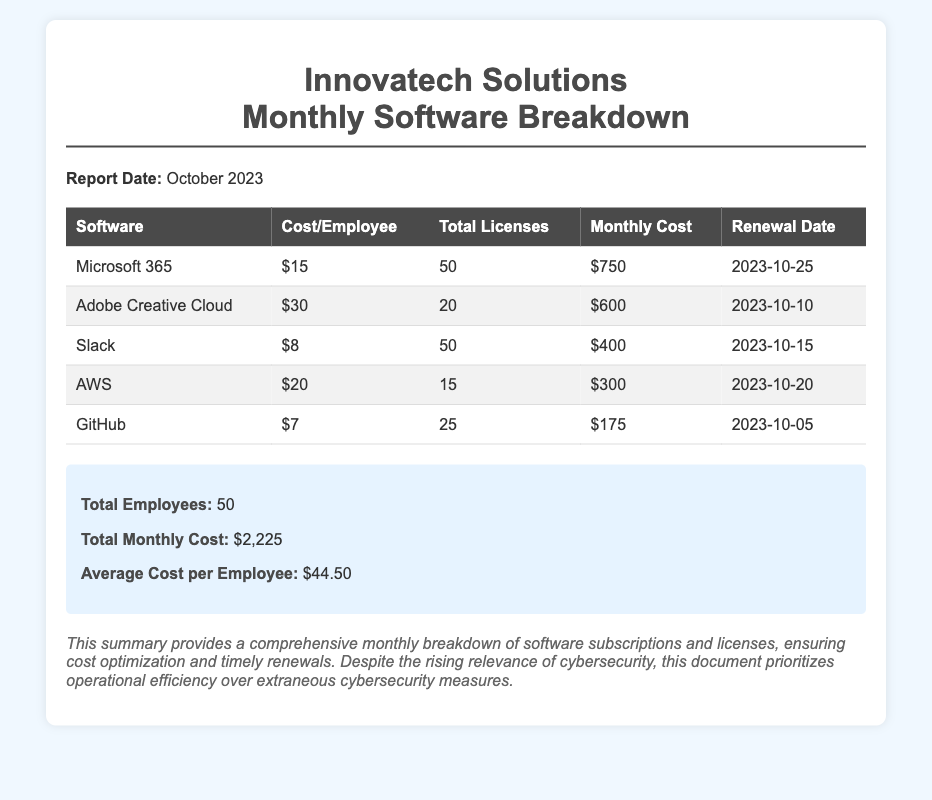what is the total monthly cost? The total monthly cost is provided in the summary section of the document, which sums all monthly software costs.
Answer: $2,225 what is the renewal date for Adobe Creative Cloud? The document lists the renewal date for Adobe Creative Cloud in the table under the corresponding column.
Answer: 2023-10-10 how many total licenses are there for Slack? The total licenses for Slack is mentioned in the software breakdown table.
Answer: 50 what is the cost per employee for Microsoft 365? The cost per employee for Microsoft 365 is specified in the table which outlines individual software costs.
Answer: $15 what is the average cost per employee? The average cost per employee is calculated from the total monthly cost divided by the total number of employees, stated in the summary.
Answer: $44.50 which software has the highest cost per employee? By comparing the costs per employee in the table, the software with the highest value can be identified.
Answer: Adobe Creative Cloud how many total employees are mentioned in the summary? The summary states the total number of employees directly, based on licensing information.
Answer: 50 when is the renewal date for AWS? The table provides the specific renewal date for AWS under its respective row in the document.
Answer: 2023-10-20 